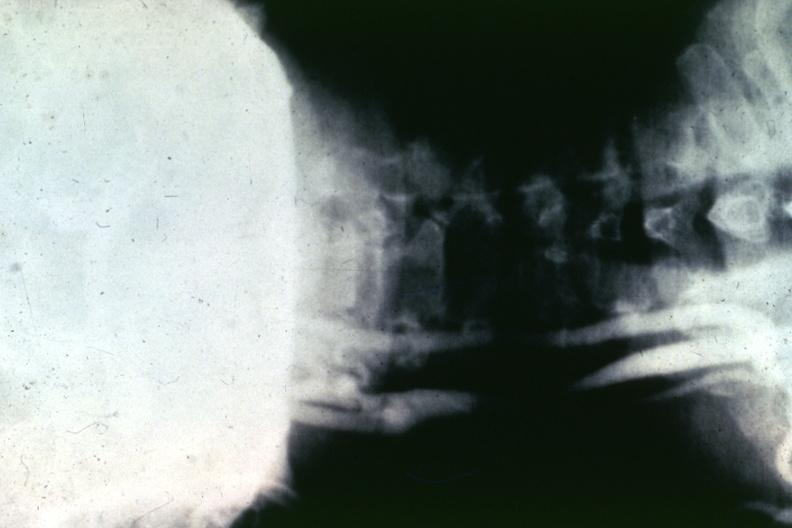does chronic ischemia show artery?
Answer the question using a single word or phrase. No 